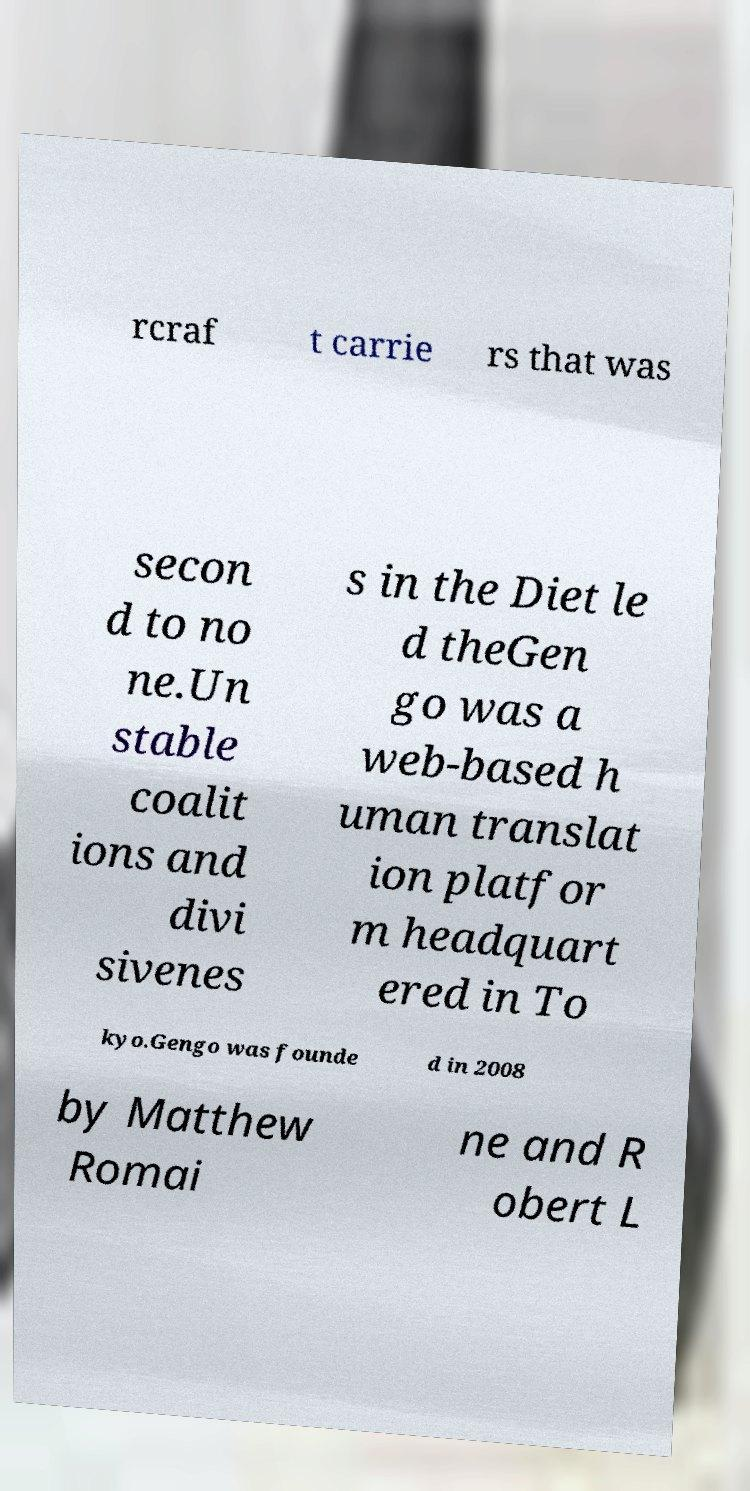I need the written content from this picture converted into text. Can you do that? rcraf t carrie rs that was secon d to no ne.Un stable coalit ions and divi sivenes s in the Diet le d theGen go was a web-based h uman translat ion platfor m headquart ered in To kyo.Gengo was founde d in 2008 by Matthew Romai ne and R obert L 